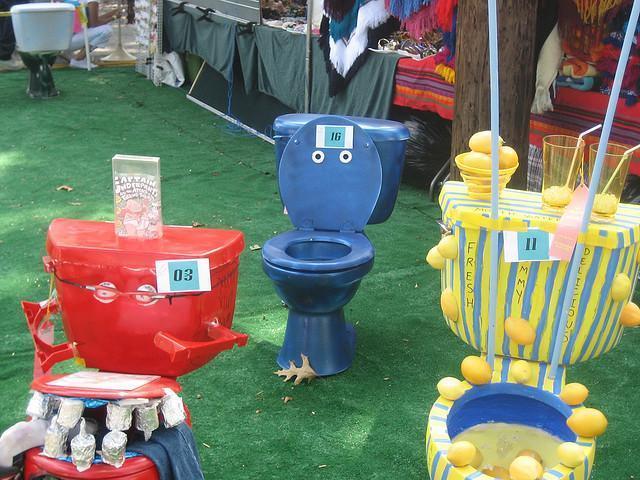How many toilets can be seen?
Give a very brief answer. 4. 